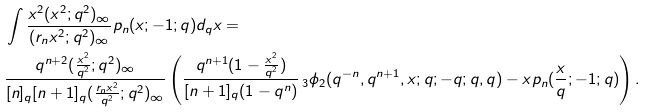<formula> <loc_0><loc_0><loc_500><loc_500>& \int \frac { x ^ { 2 } ( x ^ { 2 } ; q ^ { 2 } ) _ { \infty } } { ( r _ { n } x ^ { 2 } ; q ^ { 2 } ) _ { \infty } } p _ { n } ( x ; - 1 ; q ) d _ { q } x = \\ & \frac { q ^ { n + 2 } ( \frac { x ^ { 2 } } { q ^ { 2 } } ; q ^ { 2 } ) _ { \infty } } { [ n ] _ { q } [ n + 1 ] _ { q } ( \frac { r _ { n } x ^ { 2 } } { q ^ { 2 } } ; q ^ { 2 } ) _ { \infty } } \left ( \frac { q ^ { n + 1 } ( 1 - \frac { x ^ { 2 } } { q ^ { 2 } } ) } { [ n + 1 ] _ { q } ( 1 - q ^ { n } ) } \, _ { 3 } \phi _ { 2 } ( q ^ { - n } , q ^ { n + 1 } , x ; q ; - q ; q , q ) - x p _ { n } ( \frac { x } { q } ; - 1 ; q ) \right ) .</formula> 